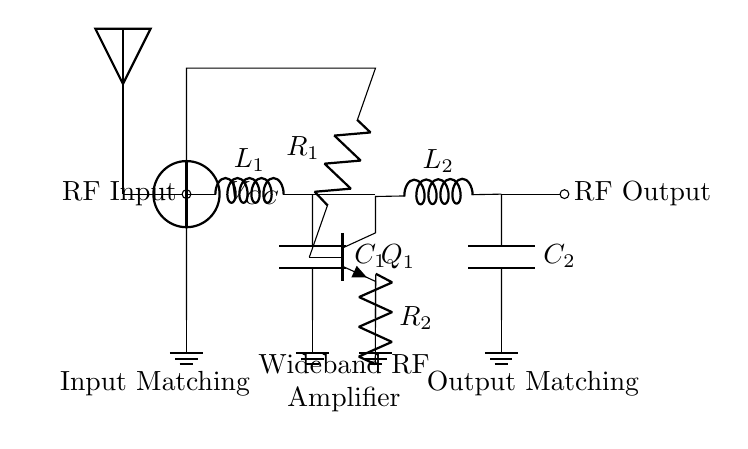What is the type of transistor used in this circuit? The circuit uses an NPN transistor, denoted by the symbol Q, which is labeled Q1 in the diagram. NPN transistors are typically used for amplification in RF applications.
Answer: NPN What component provides the output matching? The output matching is accomplished by the inductor L2 followed by the capacitor C2. This combination helps optimize the signal for transmission by matching the output impedance.
Answer: L2 and C2 What does the voltage labeled VCC represent? VCC represents the supply voltage for the circuit, which powers the transistor and other components. It is critical for the operation of the amplifier to ensure it functions within its designed parameters.
Answer: Supply voltage How many passive components are present in the circuit? The circuit contains four passive components: two inductors (L1 and L2) and two capacitors (C1 and C2). These components are essential for the matching networks in RF amplifiers.
Answer: Four What is the function of the biasing resistors? The biasing resistors R1 and R2 set the operating point of the transistor Q1, ensuring it is in the correct region of operation for amplification. They control the base and emitter currents to stabilize the amplification process.
Answer: Operating point stabilization Which section of the circuit is responsible for input matching? The input matching is handled by the components labeled as L1 and C1. This section is designed to maximize power transfer from the antenna to the amplifier by minimizing reflections.
Answer: L1 and C1 